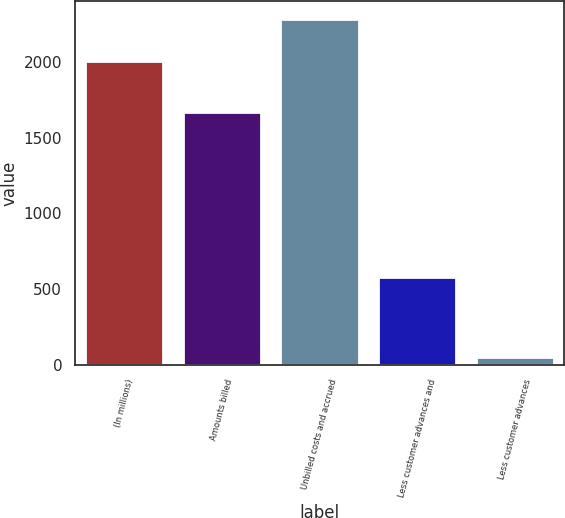Convert chart. <chart><loc_0><loc_0><loc_500><loc_500><bar_chart><fcel>(In millions)<fcel>Amounts billed<fcel>Unbilled costs and accrued<fcel>Less customer advances and<fcel>Less customer advances<nl><fcel>2006<fcel>1671<fcel>2284<fcel>579<fcel>53<nl></chart> 